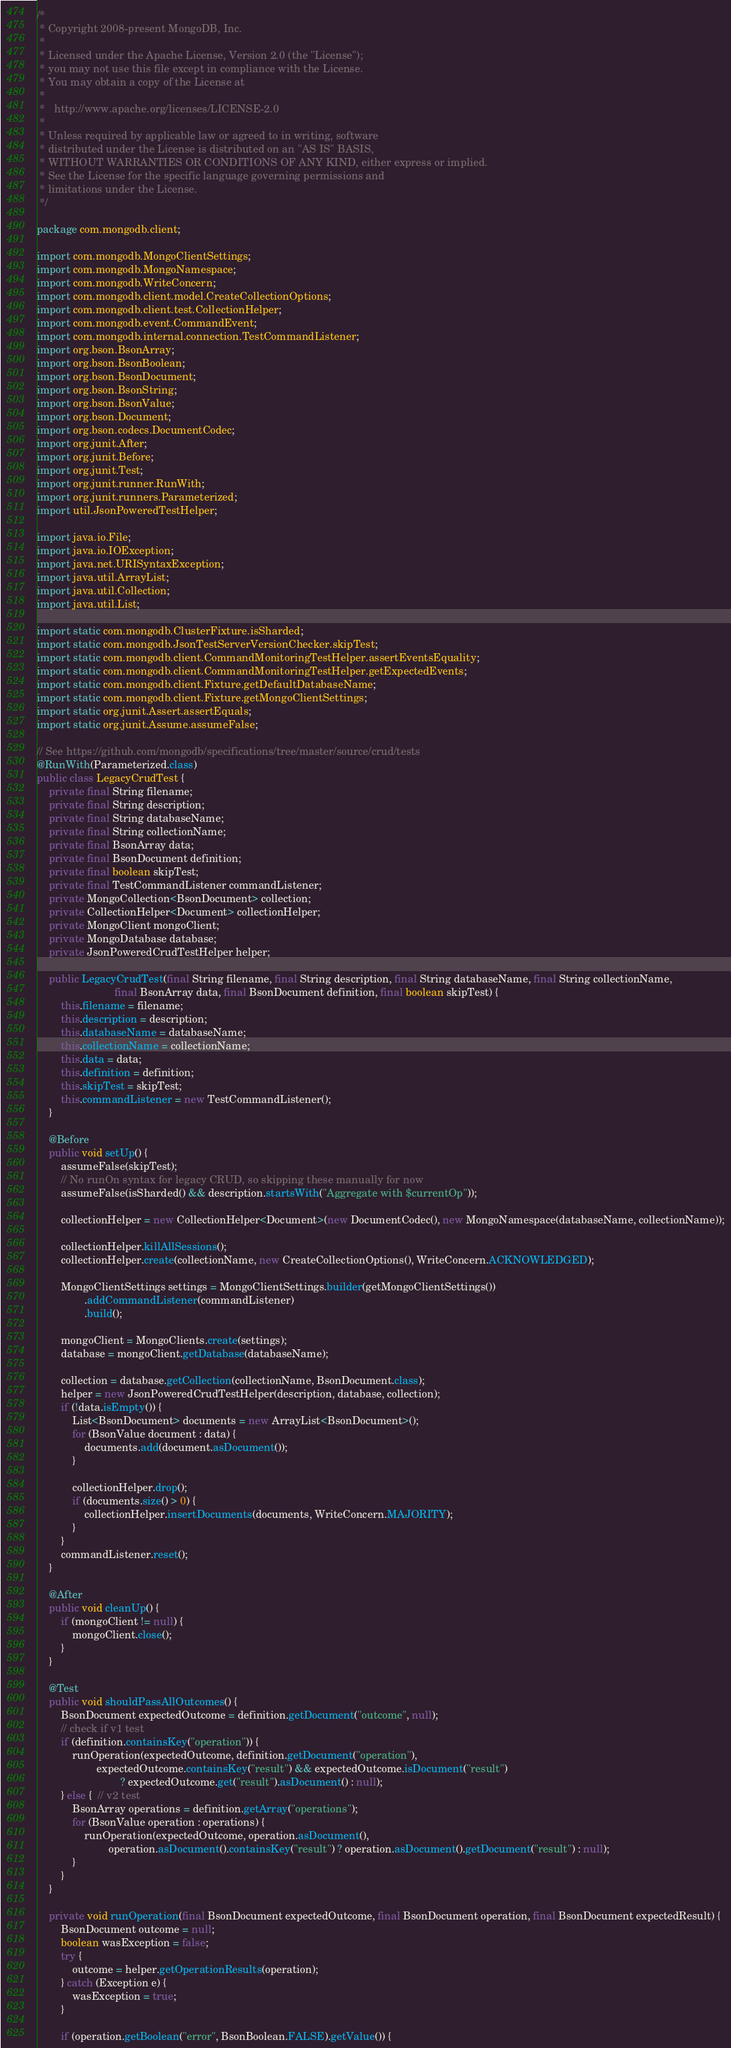<code> <loc_0><loc_0><loc_500><loc_500><_Java_>/*
 * Copyright 2008-present MongoDB, Inc.
 *
 * Licensed under the Apache License, Version 2.0 (the "License");
 * you may not use this file except in compliance with the License.
 * You may obtain a copy of the License at
 *
 *   http://www.apache.org/licenses/LICENSE-2.0
 *
 * Unless required by applicable law or agreed to in writing, software
 * distributed under the License is distributed on an "AS IS" BASIS,
 * WITHOUT WARRANTIES OR CONDITIONS OF ANY KIND, either express or implied.
 * See the License for the specific language governing permissions and
 * limitations under the License.
 */

package com.mongodb.client;

import com.mongodb.MongoClientSettings;
import com.mongodb.MongoNamespace;
import com.mongodb.WriteConcern;
import com.mongodb.client.model.CreateCollectionOptions;
import com.mongodb.client.test.CollectionHelper;
import com.mongodb.event.CommandEvent;
import com.mongodb.internal.connection.TestCommandListener;
import org.bson.BsonArray;
import org.bson.BsonBoolean;
import org.bson.BsonDocument;
import org.bson.BsonString;
import org.bson.BsonValue;
import org.bson.Document;
import org.bson.codecs.DocumentCodec;
import org.junit.After;
import org.junit.Before;
import org.junit.Test;
import org.junit.runner.RunWith;
import org.junit.runners.Parameterized;
import util.JsonPoweredTestHelper;

import java.io.File;
import java.io.IOException;
import java.net.URISyntaxException;
import java.util.ArrayList;
import java.util.Collection;
import java.util.List;

import static com.mongodb.ClusterFixture.isSharded;
import static com.mongodb.JsonTestServerVersionChecker.skipTest;
import static com.mongodb.client.CommandMonitoringTestHelper.assertEventsEquality;
import static com.mongodb.client.CommandMonitoringTestHelper.getExpectedEvents;
import static com.mongodb.client.Fixture.getDefaultDatabaseName;
import static com.mongodb.client.Fixture.getMongoClientSettings;
import static org.junit.Assert.assertEquals;
import static org.junit.Assume.assumeFalse;

// See https://github.com/mongodb/specifications/tree/master/source/crud/tests
@RunWith(Parameterized.class)
public class LegacyCrudTest {
    private final String filename;
    private final String description;
    private final String databaseName;
    private final String collectionName;
    private final BsonArray data;
    private final BsonDocument definition;
    private final boolean skipTest;
    private final TestCommandListener commandListener;
    private MongoCollection<BsonDocument> collection;
    private CollectionHelper<Document> collectionHelper;
    private MongoClient mongoClient;
    private MongoDatabase database;
    private JsonPoweredCrudTestHelper helper;

    public LegacyCrudTest(final String filename, final String description, final String databaseName, final String collectionName,
                          final BsonArray data, final BsonDocument definition, final boolean skipTest) {
        this.filename = filename;
        this.description = description;
        this.databaseName = databaseName;
        this.collectionName = collectionName;
        this.data = data;
        this.definition = definition;
        this.skipTest = skipTest;
        this.commandListener = new TestCommandListener();
    }

    @Before
    public void setUp() {
        assumeFalse(skipTest);
        // No runOn syntax for legacy CRUD, so skipping these manually for now
        assumeFalse(isSharded() && description.startsWith("Aggregate with $currentOp"));

        collectionHelper = new CollectionHelper<Document>(new DocumentCodec(), new MongoNamespace(databaseName, collectionName));

        collectionHelper.killAllSessions();
        collectionHelper.create(collectionName, new CreateCollectionOptions(), WriteConcern.ACKNOWLEDGED);

        MongoClientSettings settings = MongoClientSettings.builder(getMongoClientSettings())
                .addCommandListener(commandListener)
                .build();

        mongoClient = MongoClients.create(settings);
        database = mongoClient.getDatabase(databaseName);

        collection = database.getCollection(collectionName, BsonDocument.class);
        helper = new JsonPoweredCrudTestHelper(description, database, collection);
        if (!data.isEmpty()) {
            List<BsonDocument> documents = new ArrayList<BsonDocument>();
            for (BsonValue document : data) {
                documents.add(document.asDocument());
            }

            collectionHelper.drop();
            if (documents.size() > 0) {
                collectionHelper.insertDocuments(documents, WriteConcern.MAJORITY);
            }
        }
        commandListener.reset();
    }

    @After
    public void cleanUp() {
        if (mongoClient != null) {
            mongoClient.close();
        }
    }

    @Test
    public void shouldPassAllOutcomes() {
        BsonDocument expectedOutcome = definition.getDocument("outcome", null);
        // check if v1 test
        if (definition.containsKey("operation")) {
            runOperation(expectedOutcome, definition.getDocument("operation"),
                    expectedOutcome.containsKey("result") && expectedOutcome.isDocument("result")
                            ? expectedOutcome.get("result").asDocument() : null);
        } else {  // v2 test
            BsonArray operations = definition.getArray("operations");
            for (BsonValue operation : operations) {
                runOperation(expectedOutcome, operation.asDocument(),
                        operation.asDocument().containsKey("result") ? operation.asDocument().getDocument("result") : null);
            }
        }
    }

    private void runOperation(final BsonDocument expectedOutcome, final BsonDocument operation, final BsonDocument expectedResult) {
        BsonDocument outcome = null;
        boolean wasException = false;
        try {
            outcome = helper.getOperationResults(operation);
        } catch (Exception e) {
            wasException = true;
        }

        if (operation.getBoolean("error", BsonBoolean.FALSE).getValue()) {</code> 